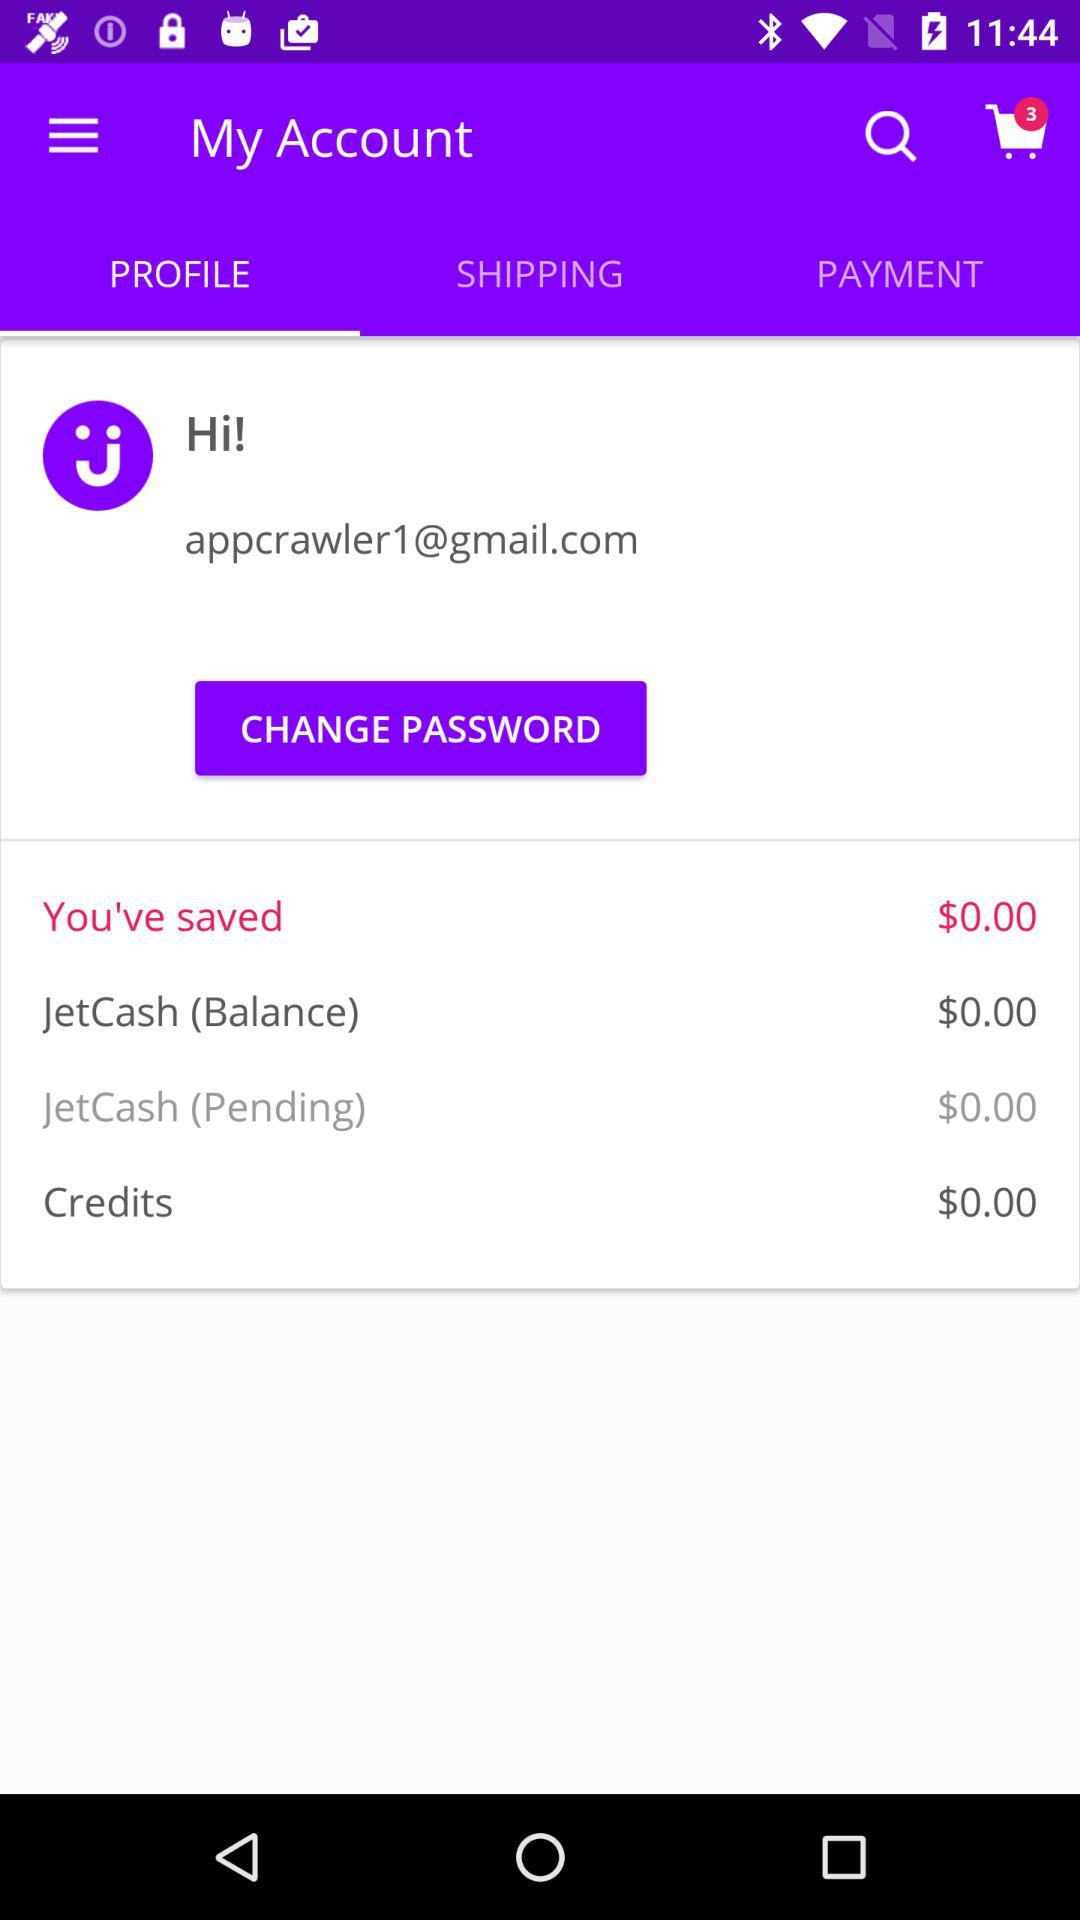What is the amount that I saved? The amount that you saved is $0. 